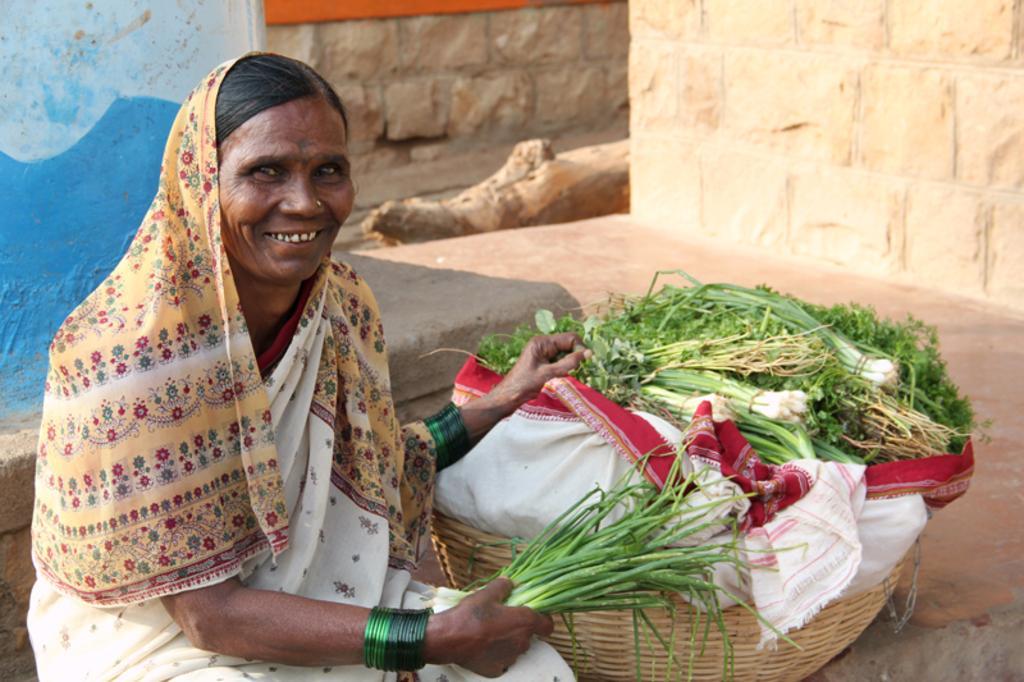Describe this image in one or two sentences. In this image we can see a woman sitting on the ground and holding a bunch of leafy vegetables in her hand. There is a basket beside her and in that we can see bunches of leafy vegetables wrapped in a cloth. 